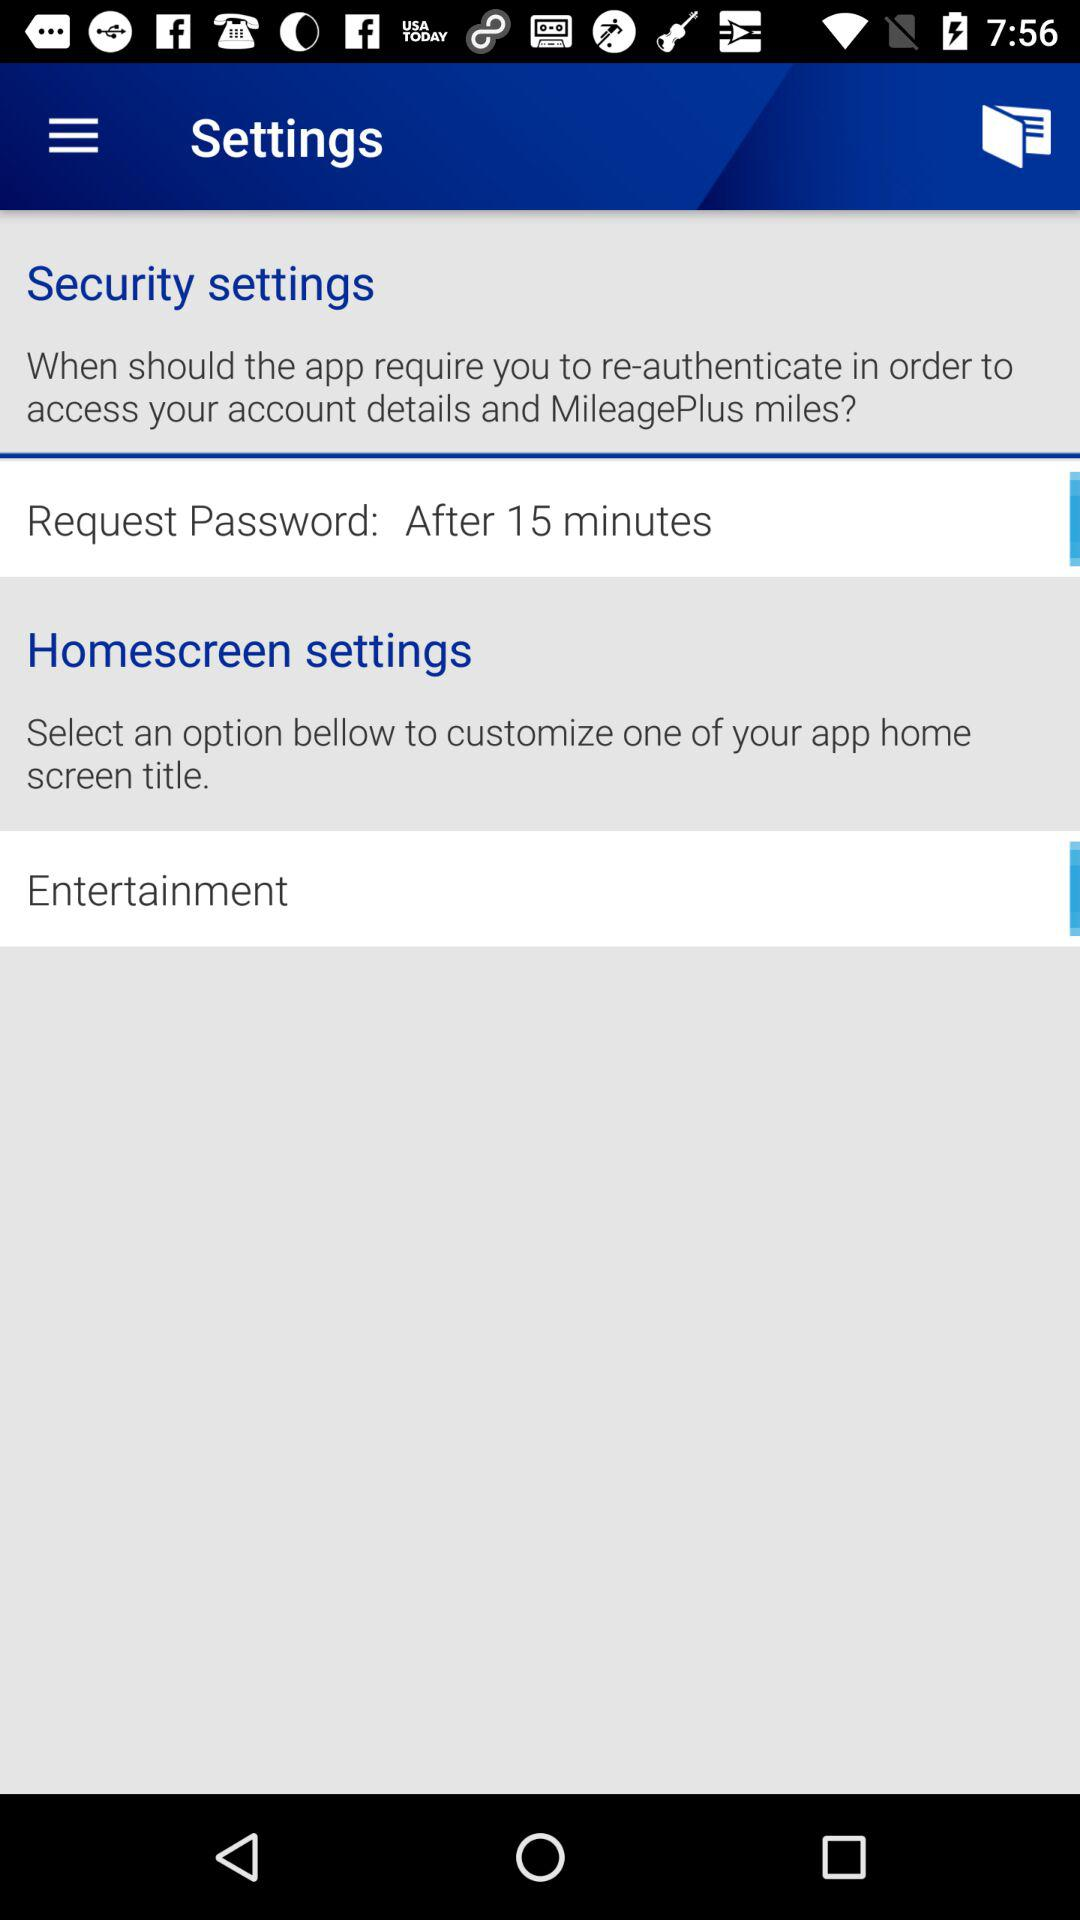What option has been given for customizing the application home screen title? The option is "Entertainment". 